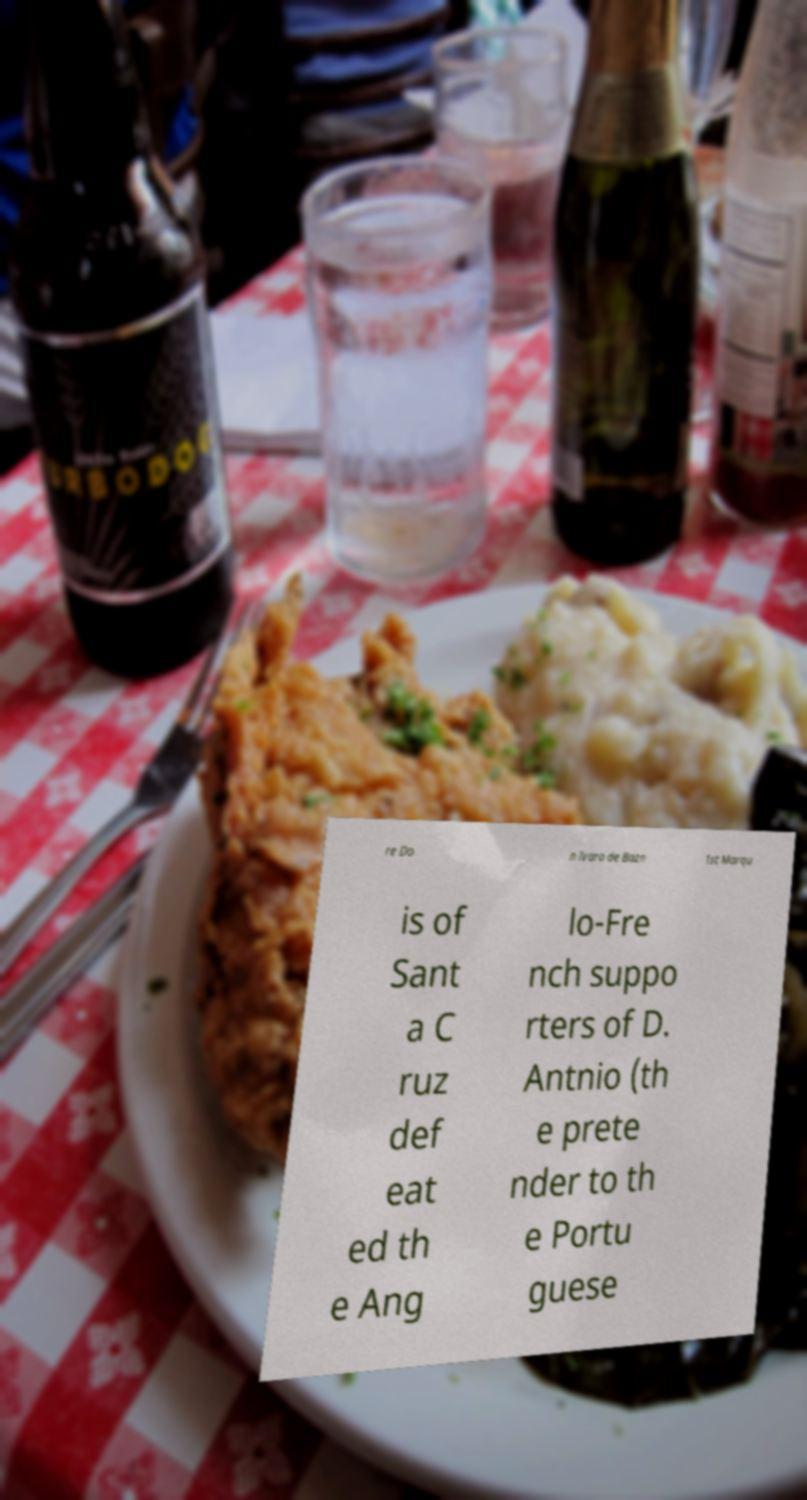For documentation purposes, I need the text within this image transcribed. Could you provide that? re Do n lvaro de Bazn 1st Marqu is of Sant a C ruz def eat ed th e Ang lo-Fre nch suppo rters of D. Antnio (th e prete nder to th e Portu guese 